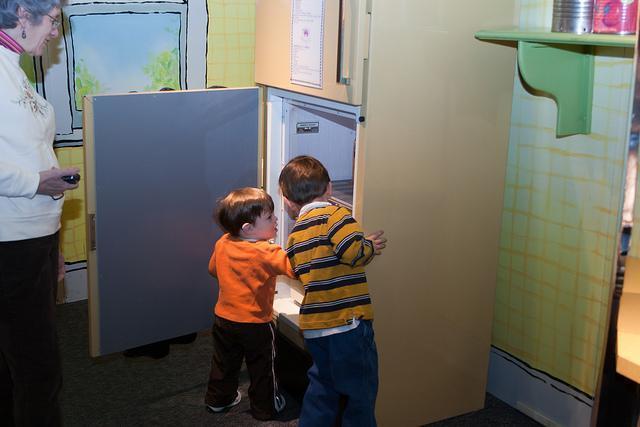How many people are in the picture?
Give a very brief answer. 3. How many people are there?
Give a very brief answer. 3. How many orange balloons are in the picture?
Give a very brief answer. 0. 